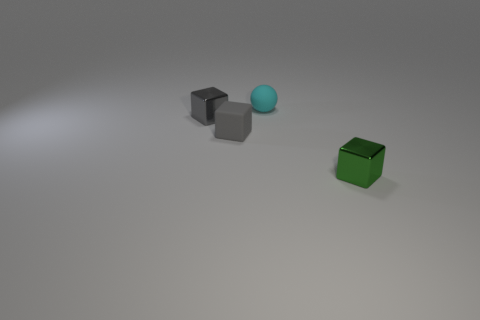What color is the thing that is in front of the small gray object in front of the metal thing that is left of the green metal thing?
Provide a short and direct response. Green. Are the cyan thing and the small cube in front of the small gray matte cube made of the same material?
Offer a terse response. No. What size is the other gray thing that is the same shape as the gray matte object?
Give a very brief answer. Small. Is the number of gray shiny blocks left of the small green shiny thing the same as the number of tiny rubber objects to the left of the tiny matte cube?
Ensure brevity in your answer.  No. What number of other objects are there of the same material as the green block?
Make the answer very short. 1. Is the number of shiny objects that are in front of the green metallic block the same as the number of tiny gray metal blocks?
Your answer should be compact. No. There is a gray rubber block; does it have the same size as the gray cube behind the gray rubber cube?
Provide a succinct answer. Yes. There is a small metal object left of the cyan object; what shape is it?
Your answer should be very brief. Cube. Is there anything else that is the same shape as the green metal object?
Provide a short and direct response. Yes. Is there a gray object?
Make the answer very short. Yes. 